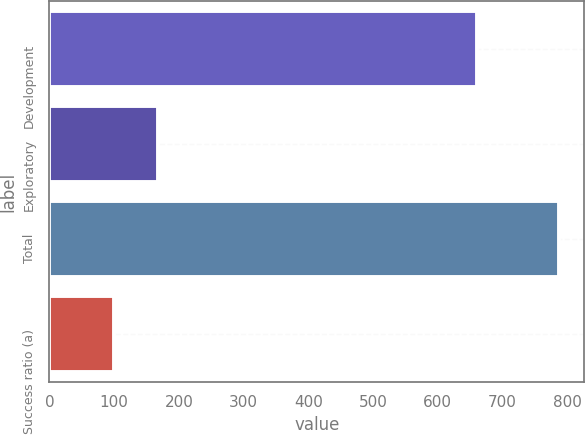<chart> <loc_0><loc_0><loc_500><loc_500><bar_chart><fcel>Development<fcel>Exploratory<fcel>Total<fcel>Success ratio (a)<nl><fcel>661<fcel>167.8<fcel>787<fcel>99<nl></chart> 